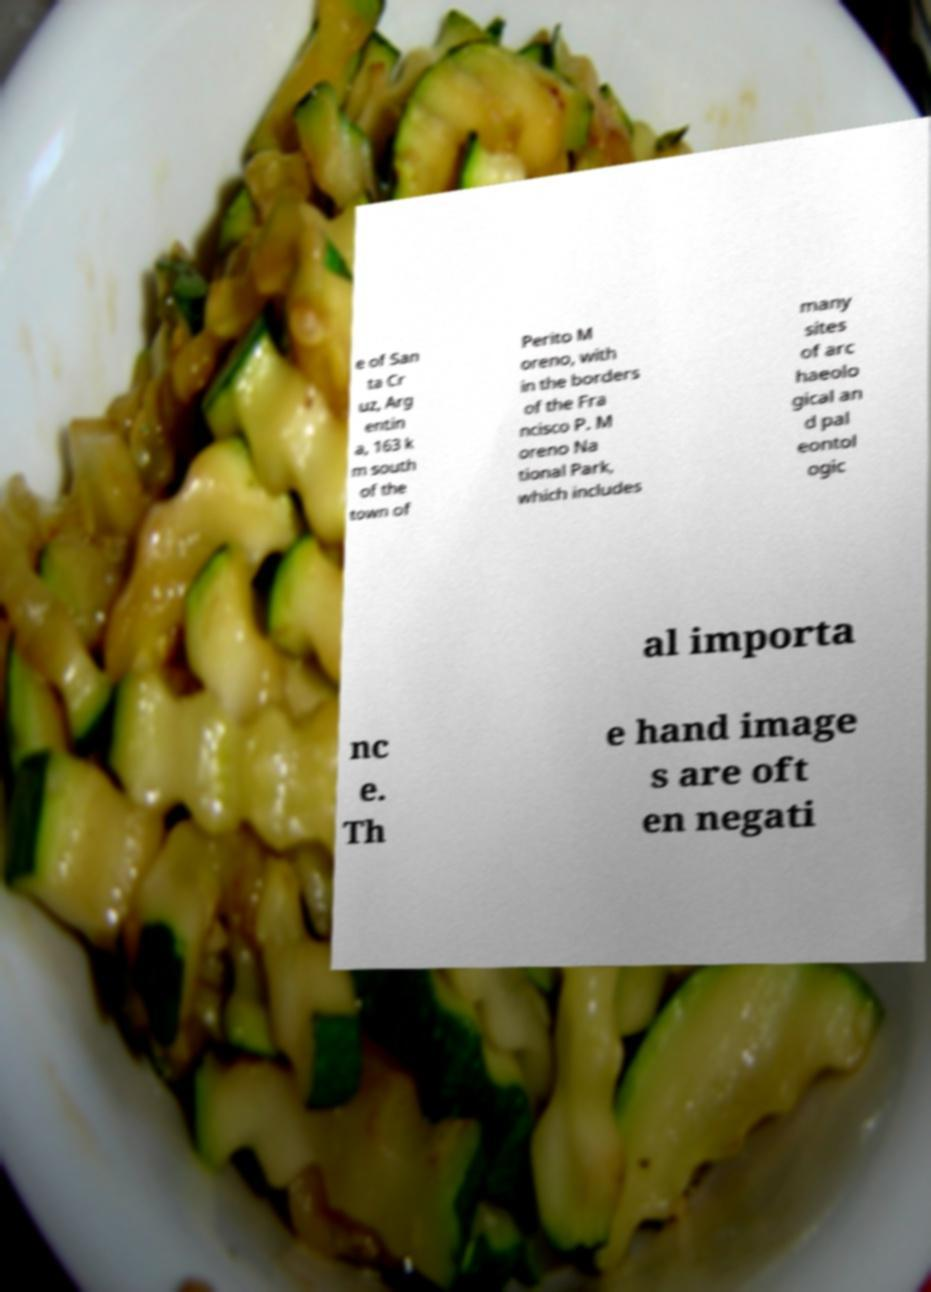Can you accurately transcribe the text from the provided image for me? e of San ta Cr uz, Arg entin a, 163 k m south of the town of Perito M oreno, with in the borders of the Fra ncisco P. M oreno Na tional Park, which includes many sites of arc haeolo gical an d pal eontol ogic al importa nc e. Th e hand image s are oft en negati 